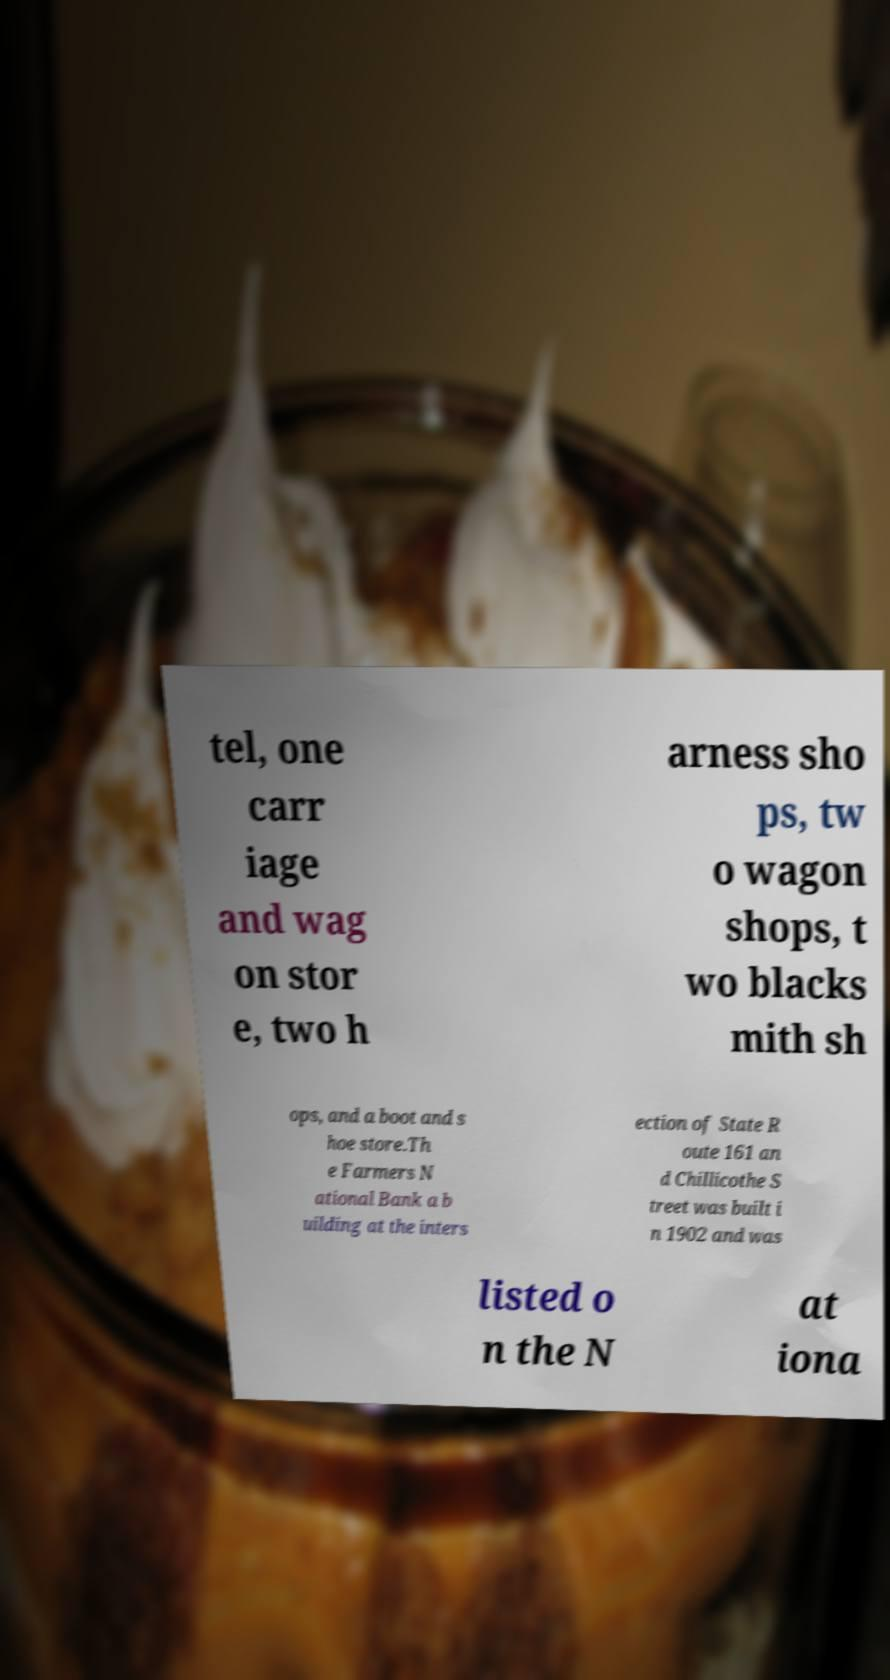Please read and relay the text visible in this image. What does it say? tel, one carr iage and wag on stor e, two h arness sho ps, tw o wagon shops, t wo blacks mith sh ops, and a boot and s hoe store.Th e Farmers N ational Bank a b uilding at the inters ection of State R oute 161 an d Chillicothe S treet was built i n 1902 and was listed o n the N at iona 